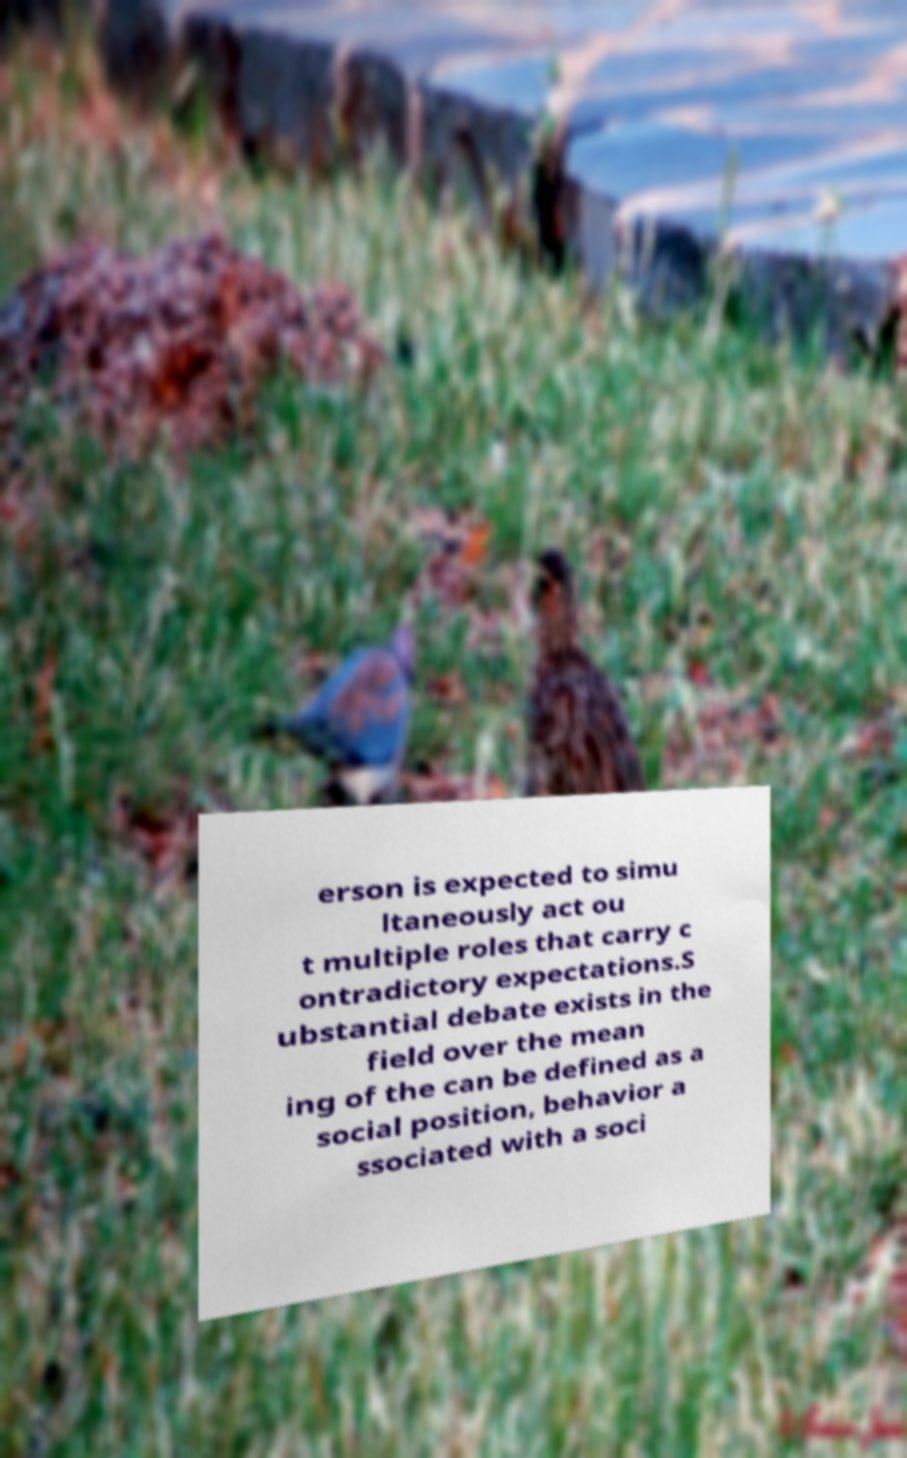For documentation purposes, I need the text within this image transcribed. Could you provide that? erson is expected to simu ltaneously act ou t multiple roles that carry c ontradictory expectations.S ubstantial debate exists in the field over the mean ing of the can be defined as a social position, behavior a ssociated with a soci 